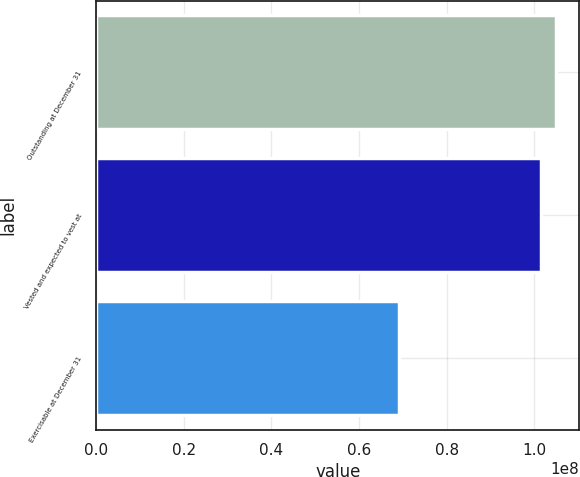Convert chart to OTSL. <chart><loc_0><loc_0><loc_500><loc_500><bar_chart><fcel>Outstanding at December 31<fcel>Vested and expected to vest at<fcel>Exercisable at December 31<nl><fcel>1.05039e+08<fcel>1.01608e+08<fcel>6.91972e+07<nl></chart> 